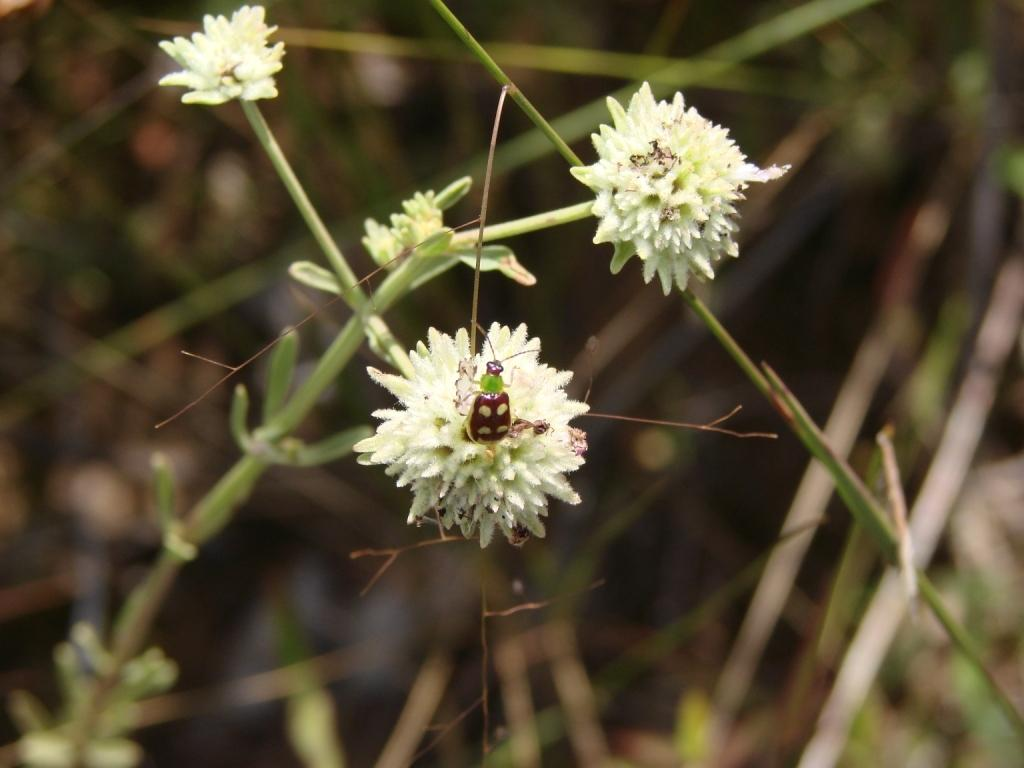What type of plant is visible in the image? There is a plant with flowers in the image. Can you describe any living organisms interacting with the plant? Yes, there is an insect on one of the flowers. What can be observed about the background of the image? The background of the image is blurry. What type of agreement is being signed by the plant in the image? There is no agreement being signed in the image; it features a plant with flowers and an insect. How does the rainstorm affect the plant in the image? There is no rainstorm present in the image; it is a plant with flowers and an insect. 